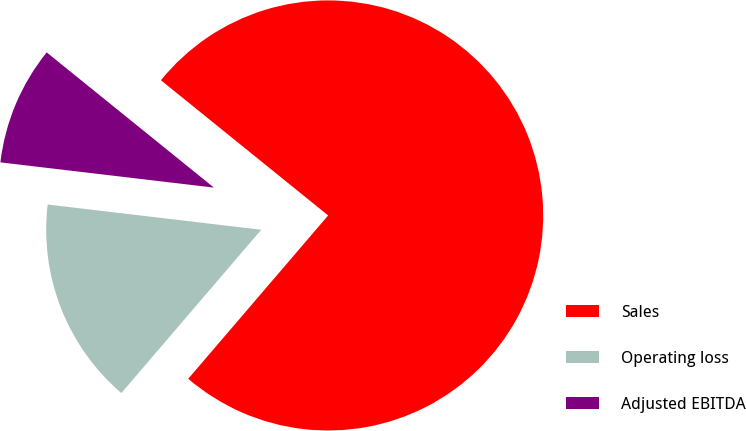Convert chart. <chart><loc_0><loc_0><loc_500><loc_500><pie_chart><fcel>Sales<fcel>Operating loss<fcel>Adjusted EBITDA<nl><fcel>75.46%<fcel>15.6%<fcel>8.95%<nl></chart> 